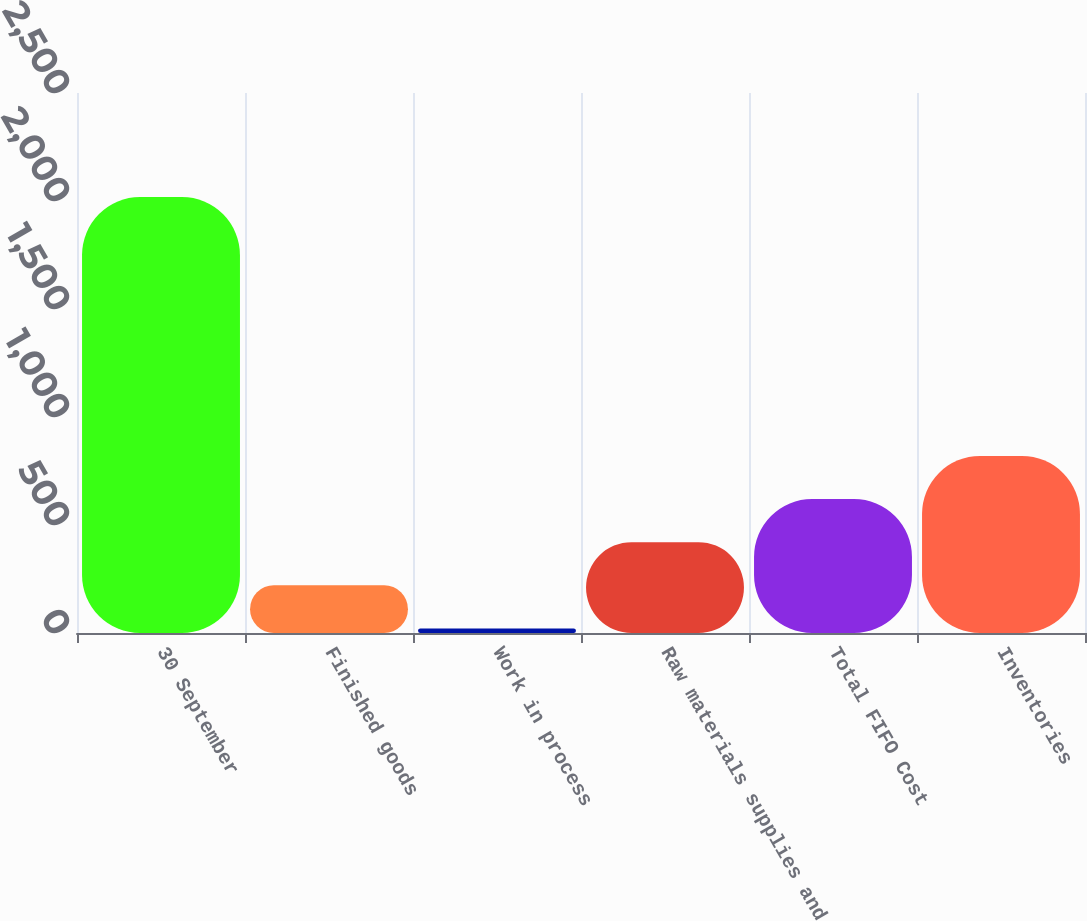Convert chart. <chart><loc_0><loc_0><loc_500><loc_500><bar_chart><fcel>30 September<fcel>Finished goods<fcel>Work in process<fcel>Raw materials supplies and<fcel>Total FIFO Cost<fcel>Inventories<nl><fcel>2018<fcel>220.88<fcel>21.2<fcel>420.56<fcel>620.24<fcel>819.92<nl></chart> 